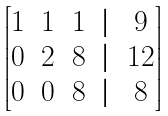<formula> <loc_0><loc_0><loc_500><loc_500>\begin{bmatrix} 1 & 1 & 1 & | & 9 \\ 0 & 2 & 8 & | & 1 2 \\ 0 & 0 & 8 & | & 8 \end{bmatrix}</formula> 